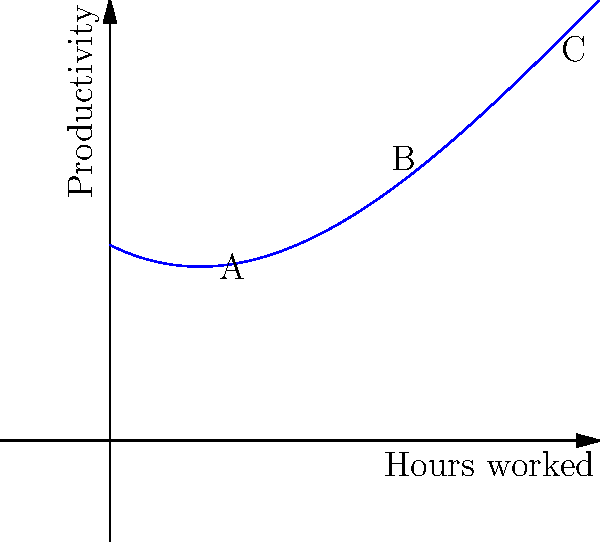As a trade union representative, you're analyzing the relationship between work hours and productivity for vocational school graduates. The graph shows a cubic function representing this relationship. What can you conclude about productivity levels at points A, B, and C? To analyze the productivity levels at points A, B, and C, we need to examine the graph and understand the cubic function's behavior:

1. Point A (around 2 hours):
   - Located near the beginning of the curve
   - Productivity is relatively low but increasing

2. Point B (around 6 hours):
   - Located near the peak of the curve
   - Represents the highest point of productivity

3. Point C (around 9 hours):
   - Located on the descending part of the curve
   - Productivity is decreasing compared to point B

The cubic function $f(x) = -0.005x^3 + 0.15x^2 - 0.5x + 4$ represents the relationship between work hours (x) and productivity (y).

The shape of the curve indicates that:
- Productivity increases rapidly at first (from A to B)
- Reaches a maximum around point B
- Starts to decrease after point B, likely due to fatigue

As a trade union representative, this analysis suggests that:
1. Short work hours (A) may not be optimal for productivity
2. There's an ideal work duration (B) for maximum productivity
3. Excessively long work hours (C) lead to decreased productivity, potentially due to worker fatigue

This information can be used to advocate for fair work hours that balance productivity and worker well-being.
Answer: A: Low but increasing productivity; B: Peak productivity; C: Decreasing productivity due to longer hours 